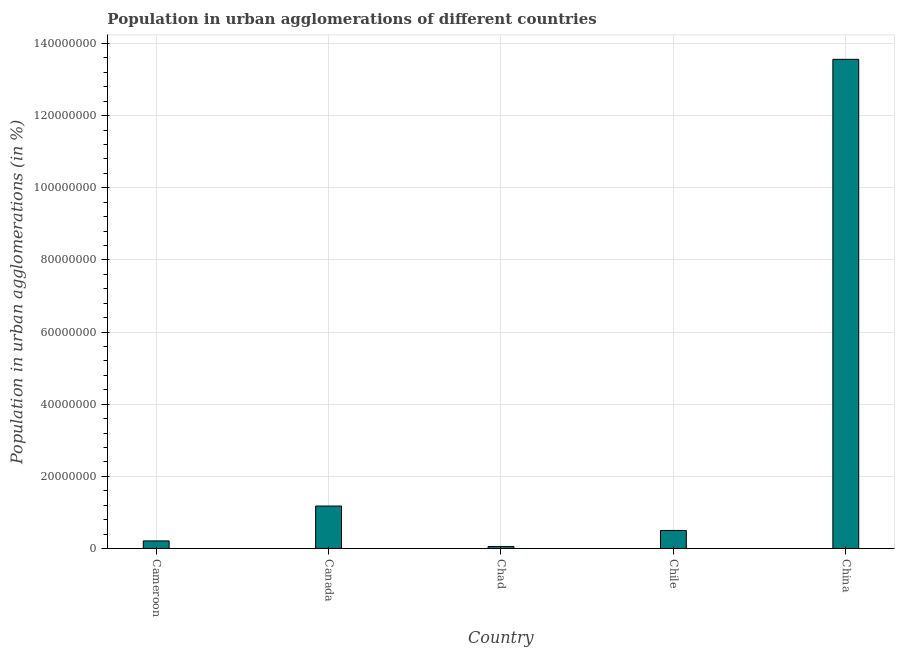What is the title of the graph?
Ensure brevity in your answer.  Population in urban agglomerations of different countries. What is the label or title of the X-axis?
Your answer should be compact. Country. What is the label or title of the Y-axis?
Your answer should be compact. Population in urban agglomerations (in %). What is the population in urban agglomerations in Chad?
Your answer should be compact. 5.57e+05. Across all countries, what is the maximum population in urban agglomerations?
Ensure brevity in your answer.  1.36e+08. Across all countries, what is the minimum population in urban agglomerations?
Your answer should be very brief. 5.57e+05. In which country was the population in urban agglomerations minimum?
Your answer should be very brief. Chad. What is the sum of the population in urban agglomerations?
Provide a succinct answer. 1.55e+08. What is the difference between the population in urban agglomerations in Cameroon and Canada?
Offer a very short reply. -9.67e+06. What is the average population in urban agglomerations per country?
Keep it short and to the point. 3.10e+07. What is the median population in urban agglomerations?
Your response must be concise. 5.00e+06. In how many countries, is the population in urban agglomerations greater than 120000000 %?
Provide a succinct answer. 1. What is the ratio of the population in urban agglomerations in Cameroon to that in Canada?
Keep it short and to the point. 0.18. Is the population in urban agglomerations in Cameroon less than that in Canada?
Make the answer very short. Yes. What is the difference between the highest and the second highest population in urban agglomerations?
Provide a succinct answer. 1.24e+08. Is the sum of the population in urban agglomerations in Cameroon and Canada greater than the maximum population in urban agglomerations across all countries?
Your answer should be very brief. No. What is the difference between the highest and the lowest population in urban agglomerations?
Ensure brevity in your answer.  1.35e+08. What is the Population in urban agglomerations (in %) of Cameroon?
Give a very brief answer. 2.10e+06. What is the Population in urban agglomerations (in %) of Canada?
Give a very brief answer. 1.18e+07. What is the Population in urban agglomerations (in %) in Chad?
Keep it short and to the point. 5.57e+05. What is the Population in urban agglomerations (in %) of Chile?
Offer a terse response. 5.00e+06. What is the Population in urban agglomerations (in %) in China?
Provide a succinct answer. 1.36e+08. What is the difference between the Population in urban agglomerations (in %) in Cameroon and Canada?
Offer a very short reply. -9.67e+06. What is the difference between the Population in urban agglomerations (in %) in Cameroon and Chad?
Provide a short and direct response. 1.54e+06. What is the difference between the Population in urban agglomerations (in %) in Cameroon and Chile?
Give a very brief answer. -2.90e+06. What is the difference between the Population in urban agglomerations (in %) in Cameroon and China?
Keep it short and to the point. -1.34e+08. What is the difference between the Population in urban agglomerations (in %) in Canada and Chad?
Make the answer very short. 1.12e+07. What is the difference between the Population in urban agglomerations (in %) in Canada and Chile?
Keep it short and to the point. 6.77e+06. What is the difference between the Population in urban agglomerations (in %) in Canada and China?
Offer a very short reply. -1.24e+08. What is the difference between the Population in urban agglomerations (in %) in Chad and Chile?
Your response must be concise. -4.44e+06. What is the difference between the Population in urban agglomerations (in %) in Chad and China?
Make the answer very short. -1.35e+08. What is the difference between the Population in urban agglomerations (in %) in Chile and China?
Ensure brevity in your answer.  -1.31e+08. What is the ratio of the Population in urban agglomerations (in %) in Cameroon to that in Canada?
Provide a short and direct response. 0.18. What is the ratio of the Population in urban agglomerations (in %) in Cameroon to that in Chad?
Your answer should be very brief. 3.77. What is the ratio of the Population in urban agglomerations (in %) in Cameroon to that in Chile?
Give a very brief answer. 0.42. What is the ratio of the Population in urban agglomerations (in %) in Cameroon to that in China?
Give a very brief answer. 0.01. What is the ratio of the Population in urban agglomerations (in %) in Canada to that in Chad?
Give a very brief answer. 21.13. What is the ratio of the Population in urban agglomerations (in %) in Canada to that in Chile?
Your answer should be very brief. 2.36. What is the ratio of the Population in urban agglomerations (in %) in Canada to that in China?
Offer a very short reply. 0.09. What is the ratio of the Population in urban agglomerations (in %) in Chad to that in Chile?
Provide a succinct answer. 0.11. What is the ratio of the Population in urban agglomerations (in %) in Chad to that in China?
Provide a succinct answer. 0. What is the ratio of the Population in urban agglomerations (in %) in Chile to that in China?
Your answer should be very brief. 0.04. 